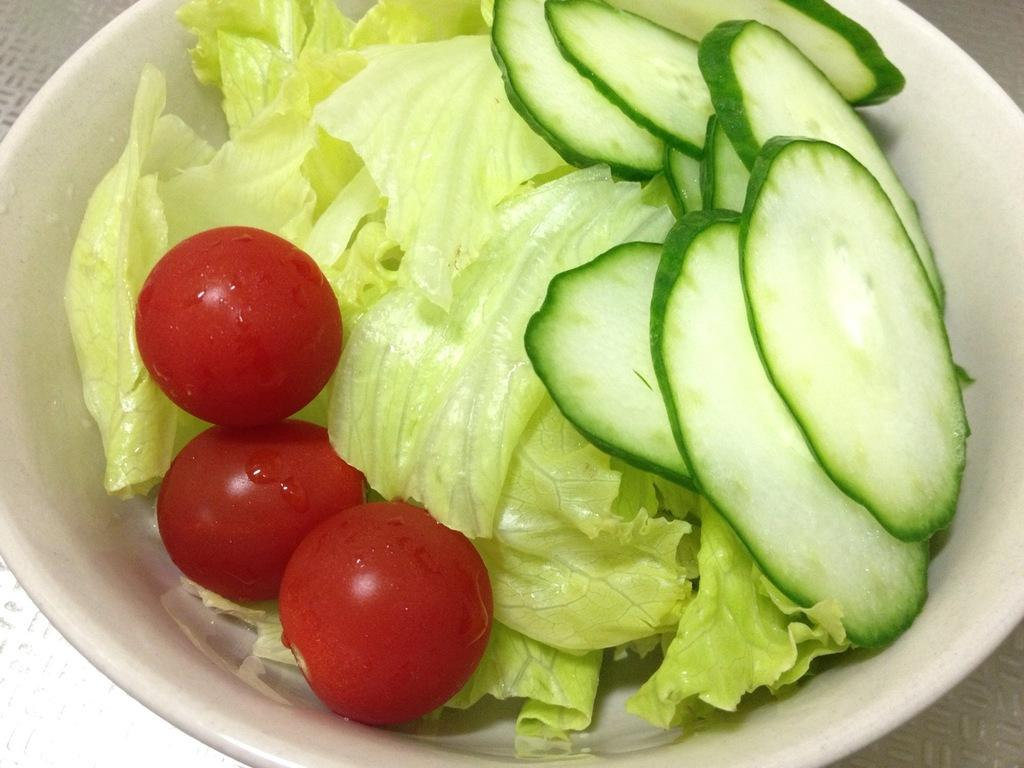What is in the bowl that is visible in the image? There are pieces of cucumber and three tomatoes in the bowl. What other vegetable is present in the bowl? There is cabbage in the bowl. How many different types of vegetables are in the bowl? There are three different types of vegetables in the bowl: cucumber, tomatoes, and cabbage. Can you see an icicle hanging from the edge of the bowl in the image? There is no icicle present in the image; it is a bowl of vegetables. 